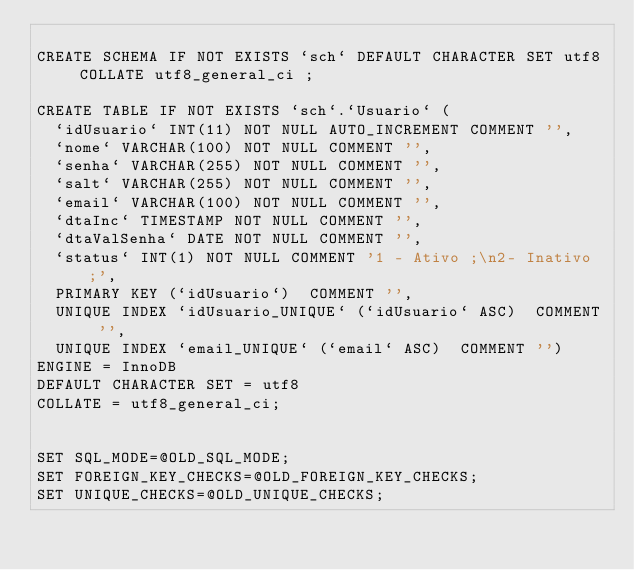<code> <loc_0><loc_0><loc_500><loc_500><_SQL_>
CREATE SCHEMA IF NOT EXISTS `sch` DEFAULT CHARACTER SET utf8 COLLATE utf8_general_ci ;

CREATE TABLE IF NOT EXISTS `sch`.`Usuario` (
  `idUsuario` INT(11) NOT NULL AUTO_INCREMENT COMMENT '',
  `nome` VARCHAR(100) NOT NULL COMMENT '',
  `senha` VARCHAR(255) NOT NULL COMMENT '',
  `salt` VARCHAR(255) NOT NULL COMMENT '',
  `email` VARCHAR(100) NOT NULL COMMENT '',
  `dtaInc` TIMESTAMP NOT NULL COMMENT '',
  `dtaValSenha` DATE NOT NULL COMMENT '',
  `status` INT(1) NOT NULL COMMENT '1 - Ativo ;\n2- Inativo ;',
  PRIMARY KEY (`idUsuario`)  COMMENT '',
  UNIQUE INDEX `idUsuario_UNIQUE` (`idUsuario` ASC)  COMMENT '',
  UNIQUE INDEX `email_UNIQUE` (`email` ASC)  COMMENT '')
ENGINE = InnoDB
DEFAULT CHARACTER SET = utf8
COLLATE = utf8_general_ci;


SET SQL_MODE=@OLD_SQL_MODE;
SET FOREIGN_KEY_CHECKS=@OLD_FOREIGN_KEY_CHECKS;
SET UNIQUE_CHECKS=@OLD_UNIQUE_CHECKS;
</code> 